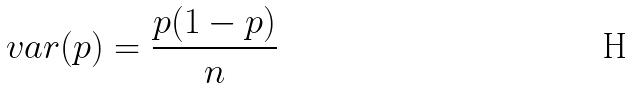Convert formula to latex. <formula><loc_0><loc_0><loc_500><loc_500>v a r ( p ) = \frac { p ( 1 - p ) } { n }</formula> 